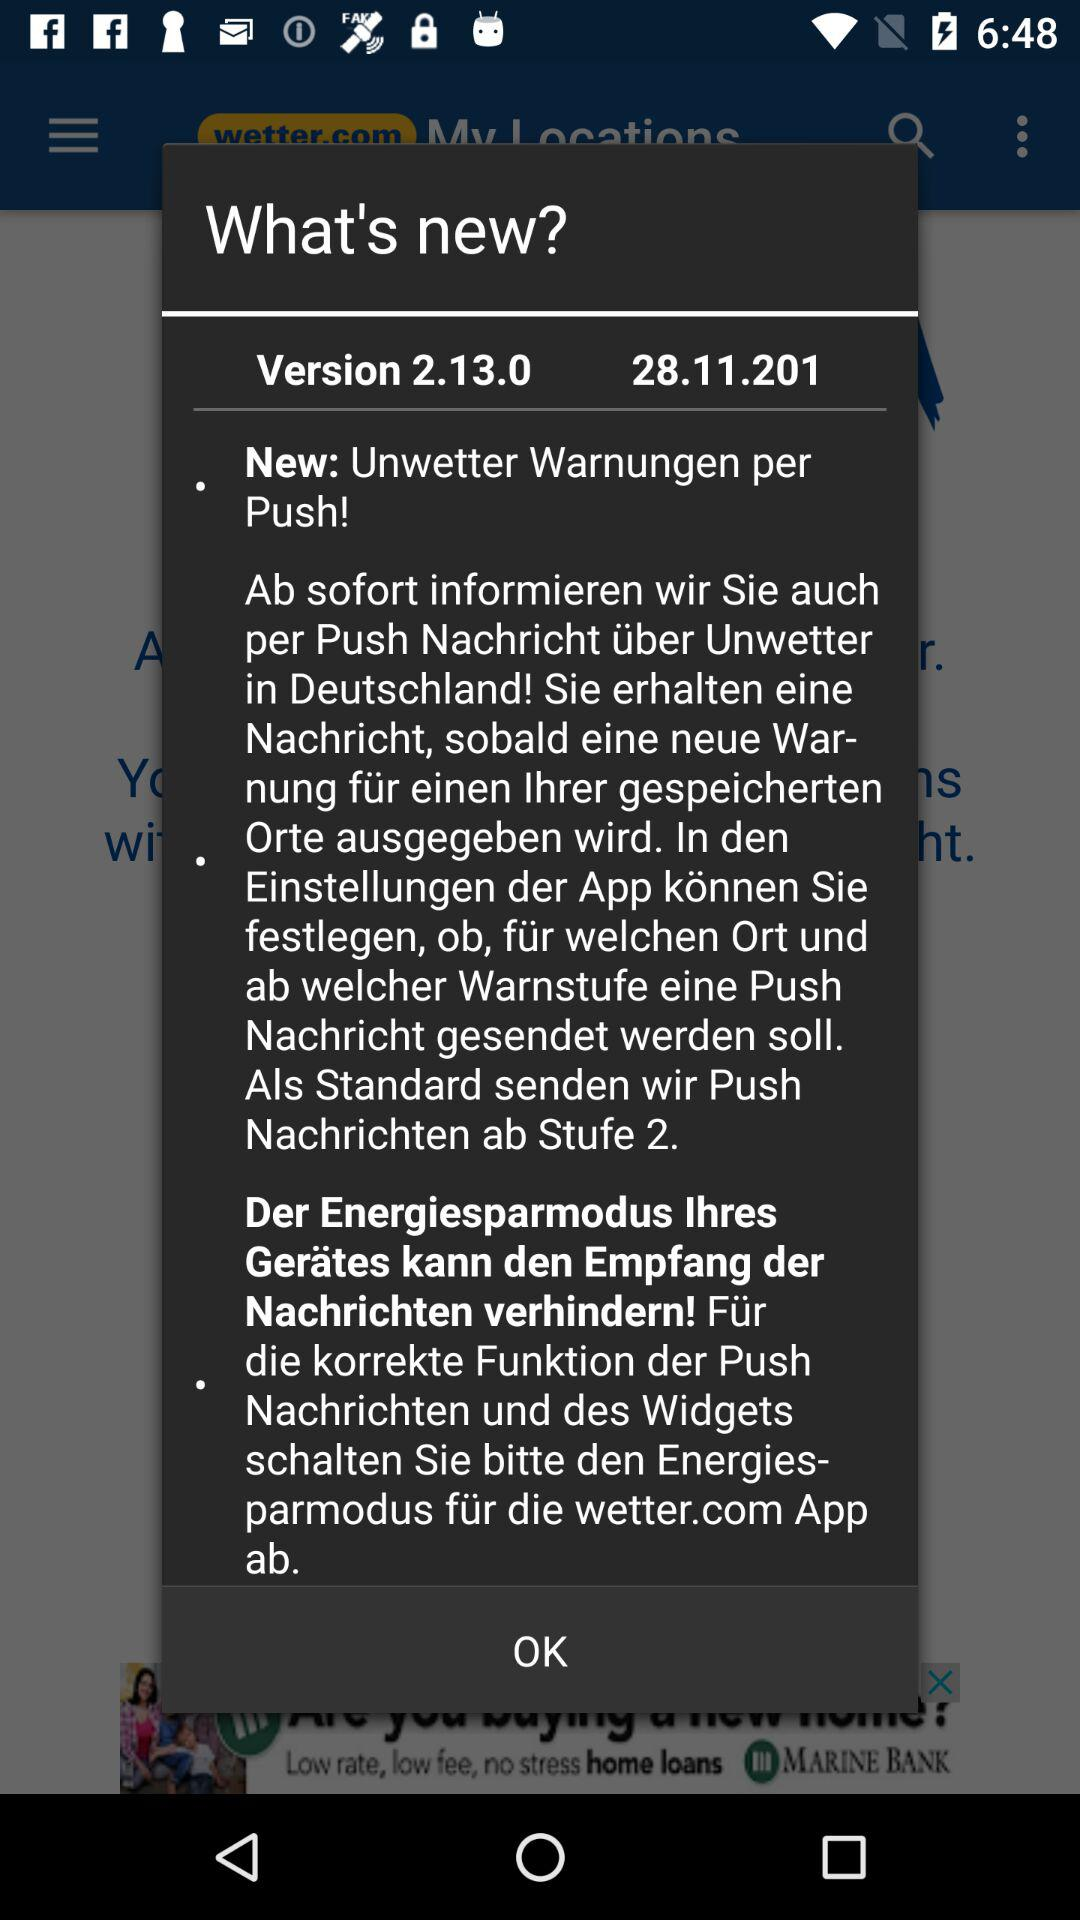Which date is mentioned there?
When the provided information is insufficient, respond with <no answer>. <no answer> 